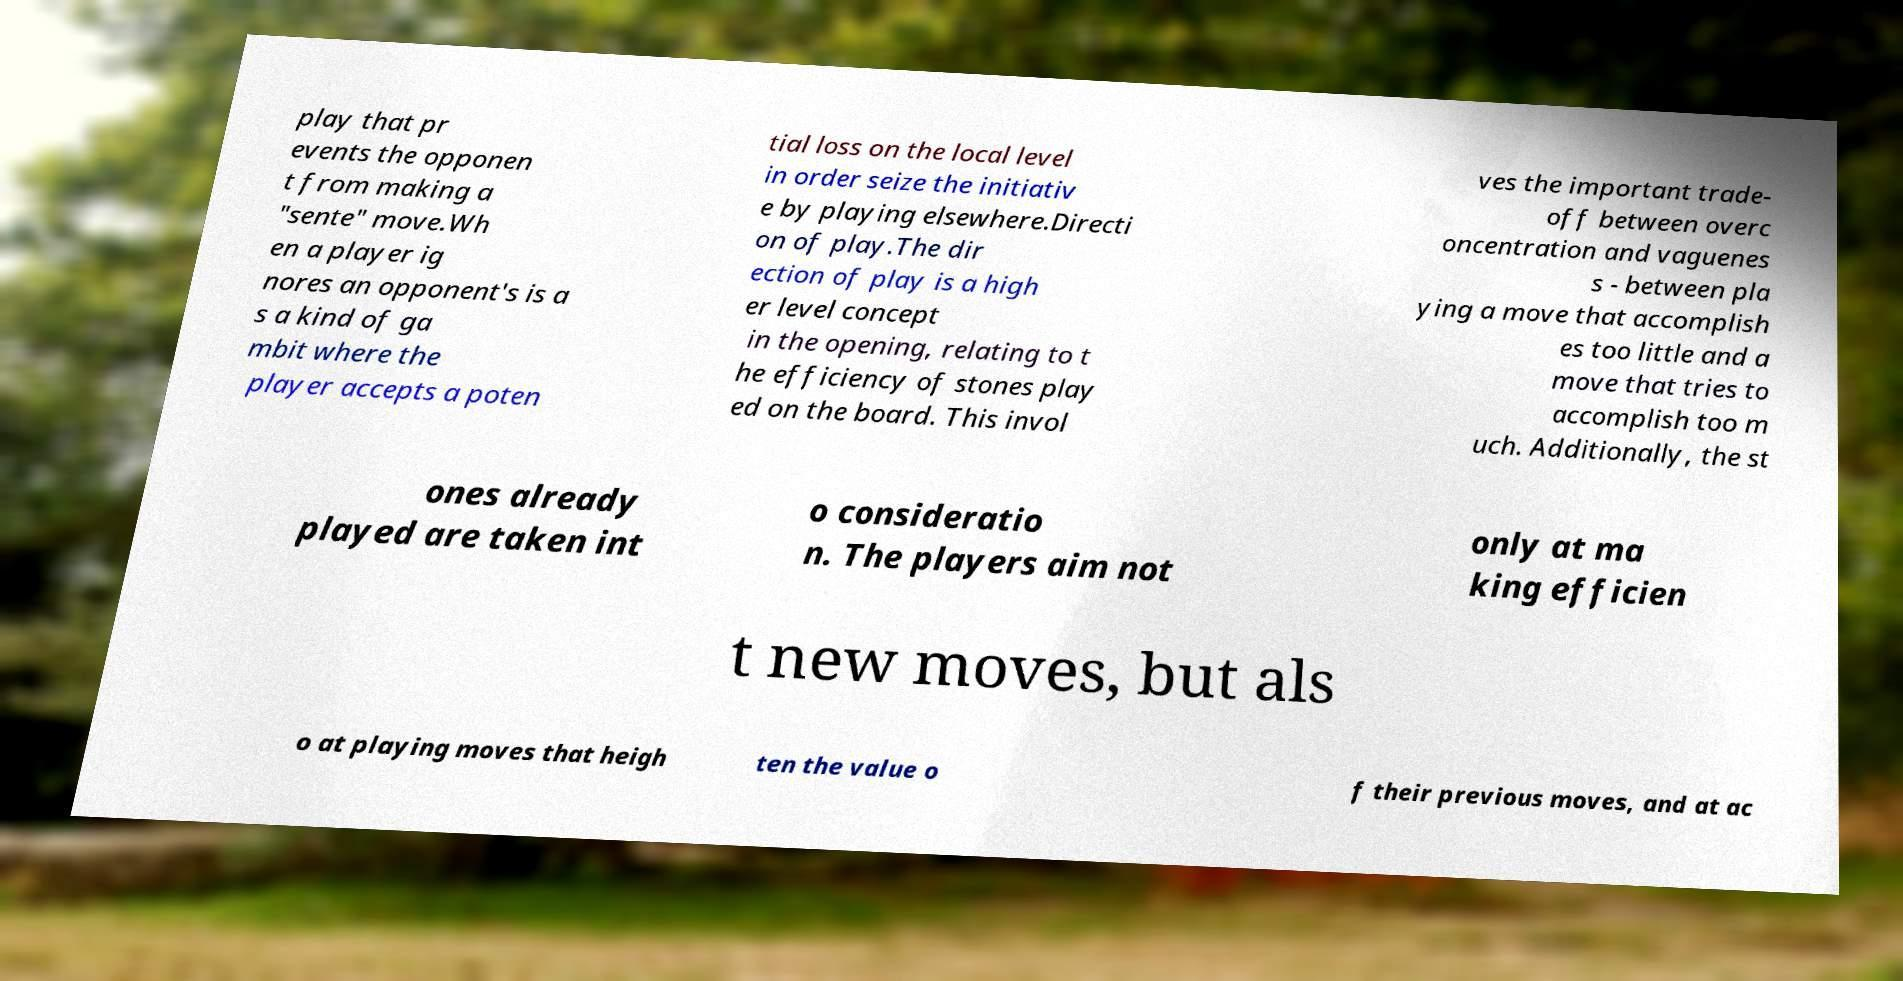Can you read and provide the text displayed in the image?This photo seems to have some interesting text. Can you extract and type it out for me? play that pr events the opponen t from making a "sente" move.Wh en a player ig nores an opponent's is a s a kind of ga mbit where the player accepts a poten tial loss on the local level in order seize the initiativ e by playing elsewhere.Directi on of play.The dir ection of play is a high er level concept in the opening, relating to t he efficiency of stones play ed on the board. This invol ves the important trade- off between overc oncentration and vaguenes s - between pla ying a move that accomplish es too little and a move that tries to accomplish too m uch. Additionally, the st ones already played are taken int o consideratio n. The players aim not only at ma king efficien t new moves, but als o at playing moves that heigh ten the value o f their previous moves, and at ac 